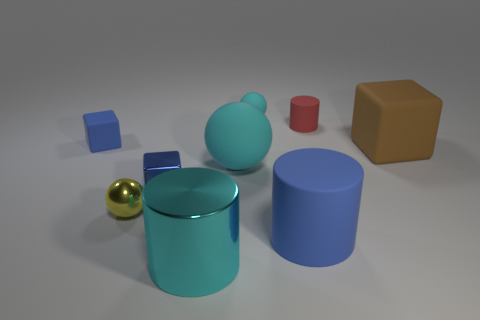Are there an equal number of rubber cylinders on the right side of the big blue cylinder and large metal cylinders that are behind the small yellow object?
Keep it short and to the point. No. Are there any gray spheres of the same size as the red cylinder?
Provide a short and direct response. No. How big is the red rubber cylinder?
Provide a succinct answer. Small. Are there an equal number of tiny red things left of the small matte cylinder and metallic spheres?
Make the answer very short. No. How many other objects are there of the same color as the big block?
Your answer should be compact. 0. What color is the block that is both behind the big cyan matte thing and left of the red cylinder?
Offer a terse response. Blue. There is a blue cube that is to the right of the matte block to the left of the blue rubber object right of the cyan shiny object; what is its size?
Your answer should be very brief. Small. What number of things are blue blocks that are in front of the tiny cyan rubber object or small objects that are in front of the big brown block?
Keep it short and to the point. 3. The tiny red rubber thing has what shape?
Your answer should be very brief. Cylinder. What number of other things are there of the same material as the tiny cyan object
Make the answer very short. 5. 